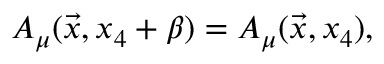<formula> <loc_0><loc_0><loc_500><loc_500>A _ { \mu } ( \vec { x } , x _ { 4 } + \beta ) = A _ { \mu } ( \vec { x } , x _ { 4 } ) ,</formula> 